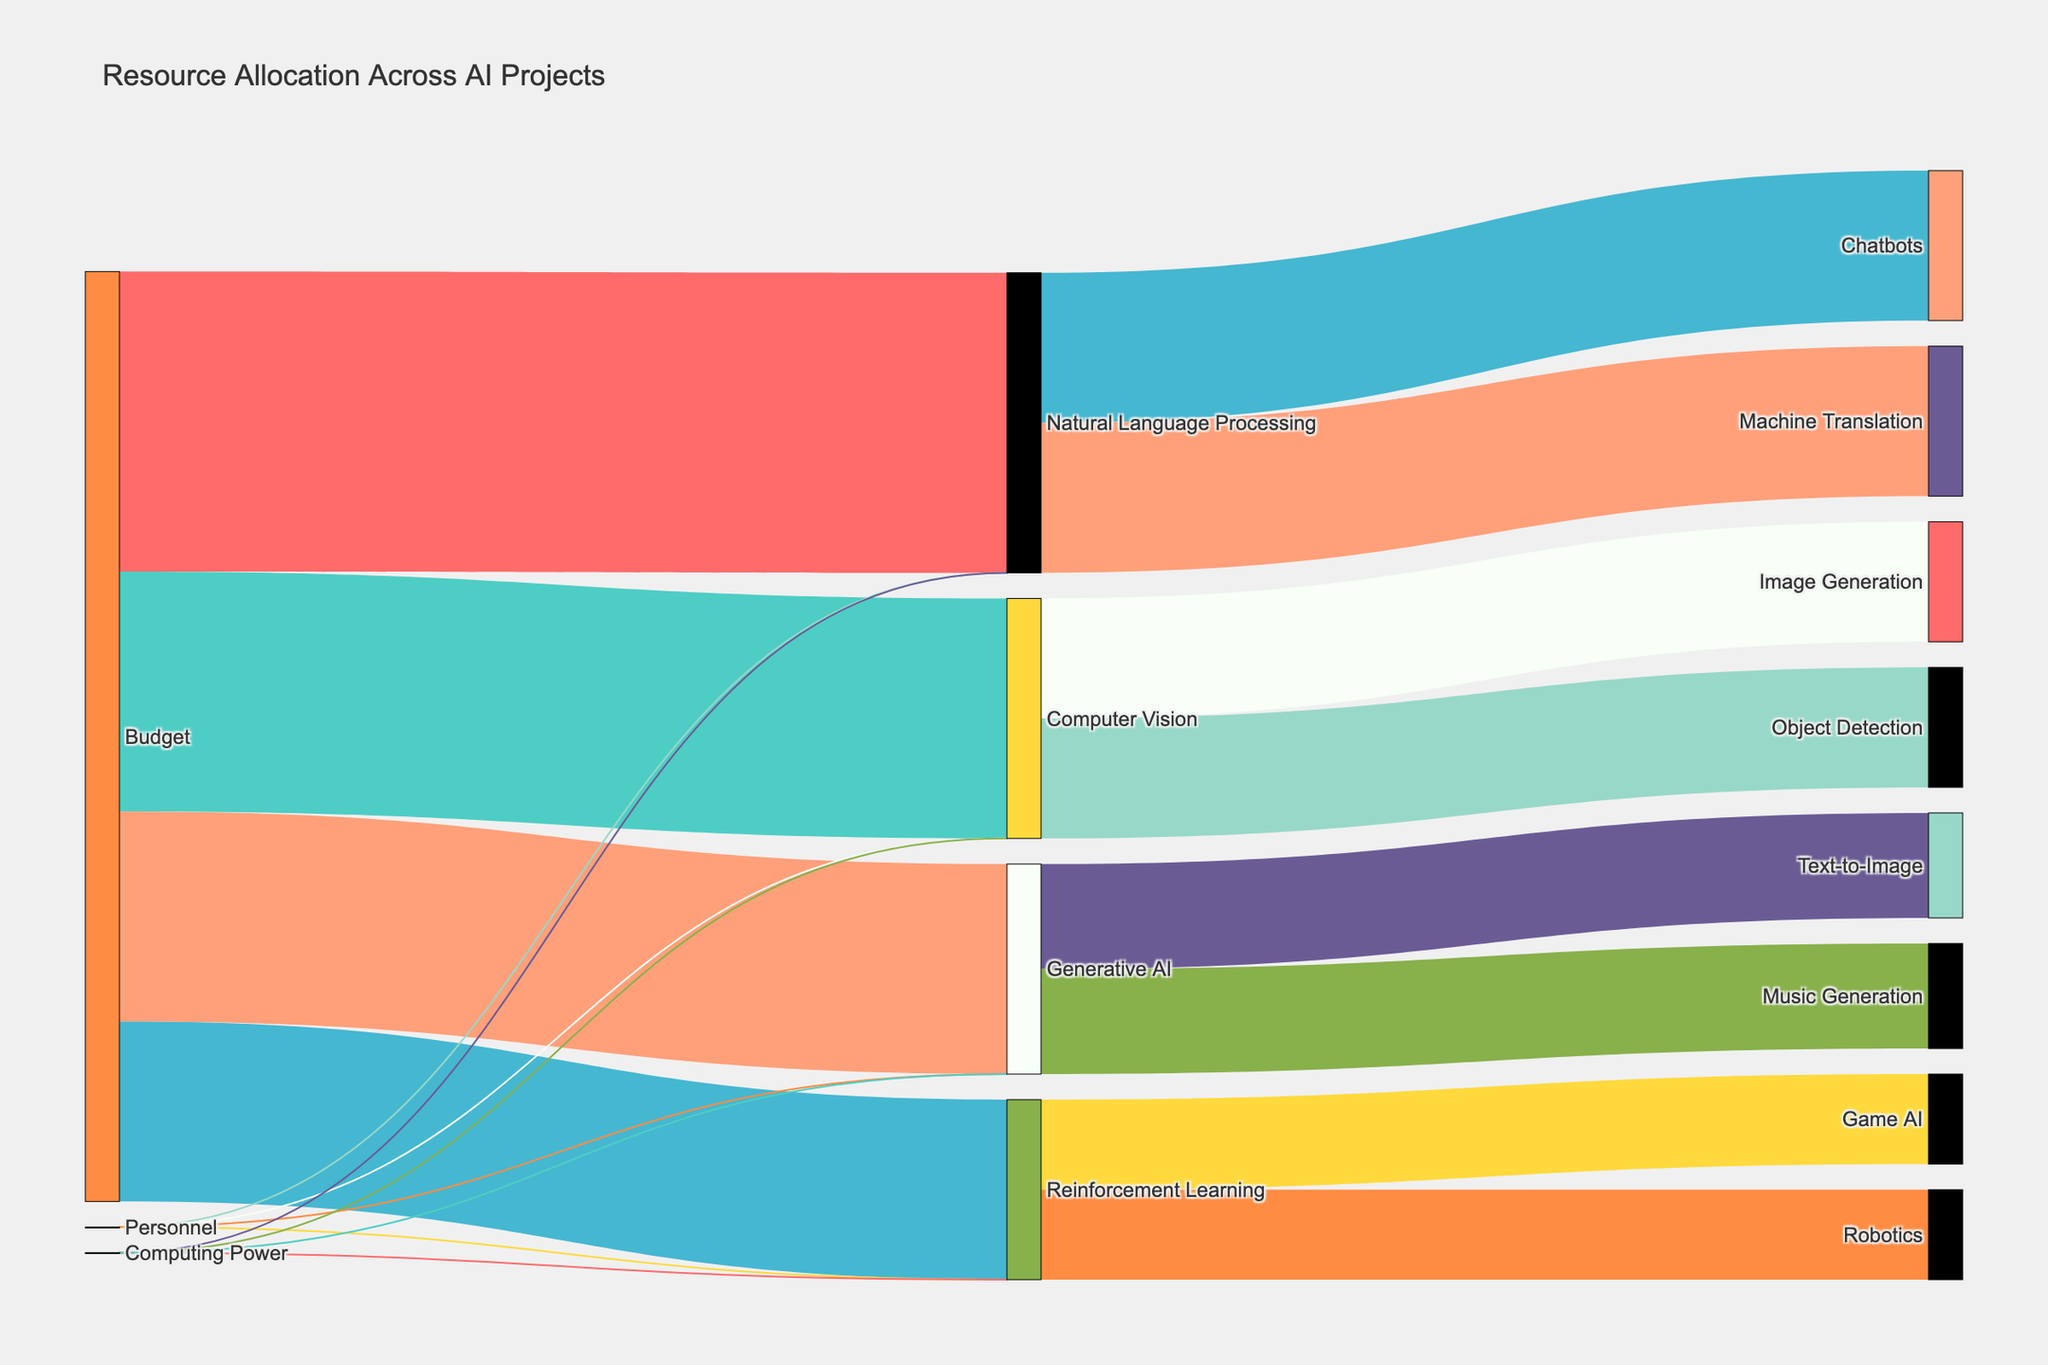What is the title of the Sankey diagram? The title of the diagram is usually displayed at the top and describes the main subject of the visualization.
Answer: Resource Allocation Across AI Projects How much budget is allocated to Natural Language Processing? Look at the flow from "Budget" to "Natural Language Processing" and note the value associated with this connection.
Answer: 5,000,000 How many personnel are involved in Generative AI projects? Check the flow from "Personnel" to "Generative AI" and observe the number of people allocated.
Answer: 35 Which AI project has the least amount of computing power allocated? Compare the values associated with the flow from "Computing Power" to each AI project and identify the smallest value.
Answer: Reinforcement Learning What is the total budget allocated across all AI projects? Add the budgets allocated to Natural Language Processing, Computer Vision, Reinforcement Learning, and Generative AI. 5,000,000 (NLP) + 4,000,000 (CV) + 3,000,000 (RL) + 3,500,000 (GAI)
Answer: 15,500,000 Which sub-project within Natural Language Processing receives the highest allocation, and what is it? Examine the flows from "Natural Language Processing" to its sub-projects and identify the highest value.
Answer: Chatbots and Machine Translation both receive 2,500,000 How does the personnel allocation compare between Computer Vision and Reinforcement Learning? Compare the number of personnel allocated to "Computer Vision" and "Reinforcement Learning" from the respective flows.
Answer: Computer Vision has 40 personnel and Reinforcement Learning has 30 personnel What is the average computing power allocated per AI project? Sum the computing power allocated to NLP, CV, RL, and GAI, then divide by the number of projects. (1000 + 800 + 600 + 700) / 4
Answer: 775 Which AI project has the largest total allocation (sum of budget, personnel, and computing power)? For each AI project, calculate the sum of its budget, personnel (consider people as a numerical count), and computing power, then compare across projects.
Answer: Natural Language Processing In the context of Generative AI, which sub-project (Text-to-Image or Music Generation) receives equal resource allocation, and what is the amount? Check the flows from "Generative AI" to its sub-projects and see if the values match.
Answer: Text-to-Image and Music Generation both receive 1,750,000 